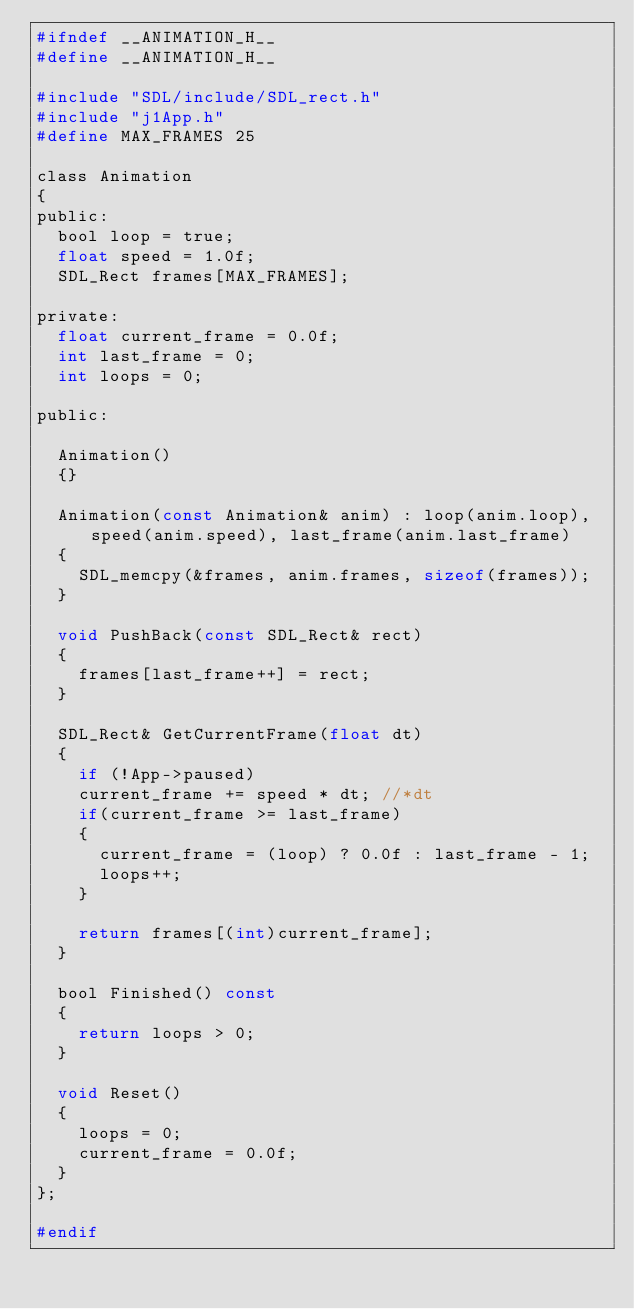<code> <loc_0><loc_0><loc_500><loc_500><_C_>#ifndef __ANIMATION_H__
#define __ANIMATION_H__

#include "SDL/include/SDL_rect.h"
#include "j1App.h"
#define MAX_FRAMES 25

class Animation
{
public:
	bool loop = true;
	float speed = 1.0f;
	SDL_Rect frames[MAX_FRAMES];

private:
	float current_frame = 0.0f;
	int last_frame = 0;
	int loops = 0;

public:

	Animation()
	{}

	Animation(const Animation& anim) : loop(anim.loop), speed(anim.speed), last_frame(anim.last_frame)
	{
		SDL_memcpy(&frames, anim.frames, sizeof(frames));
	}

	void PushBack(const SDL_Rect& rect)
	{
		frames[last_frame++] = rect;
	}

	SDL_Rect& GetCurrentFrame(float dt)
	{
		if (!App->paused)
		current_frame += speed * dt; //*dt
		if(current_frame >= last_frame)
		{
			current_frame = (loop) ? 0.0f : last_frame - 1;
			loops++;
		}

		return frames[(int)current_frame];
	}

	bool Finished() const
	{
		return loops > 0;
	}

	void Reset()
	{
		loops = 0;
		current_frame = 0.0f;
	}
};

#endif</code> 